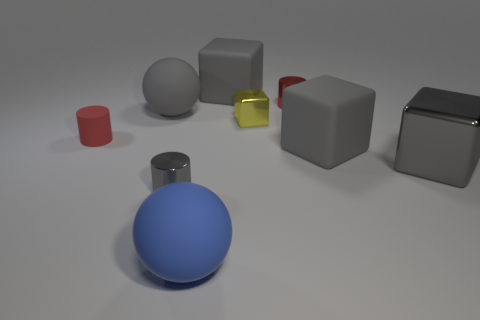Subtract all yellow cylinders. How many gray blocks are left? 3 Subtract 1 blocks. How many blocks are left? 3 Subtract all green cubes. Subtract all purple spheres. How many cubes are left? 4 Subtract all balls. How many objects are left? 7 Add 3 cylinders. How many cylinders exist? 6 Subtract 1 gray balls. How many objects are left? 8 Subtract all small red rubber cylinders. Subtract all metallic objects. How many objects are left? 4 Add 7 tiny matte objects. How many tiny matte objects are left? 8 